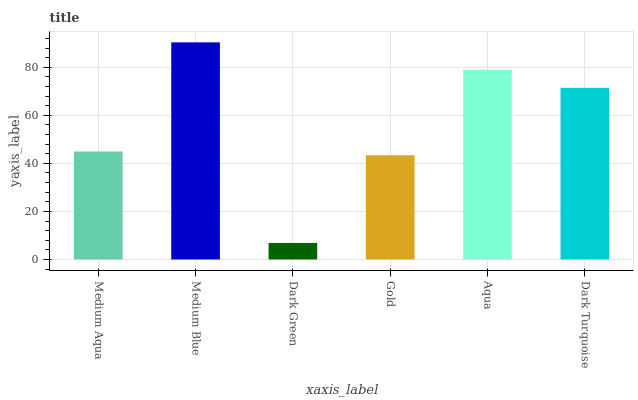Is Dark Green the minimum?
Answer yes or no. Yes. Is Medium Blue the maximum?
Answer yes or no. Yes. Is Medium Blue the minimum?
Answer yes or no. No. Is Dark Green the maximum?
Answer yes or no. No. Is Medium Blue greater than Dark Green?
Answer yes or no. Yes. Is Dark Green less than Medium Blue?
Answer yes or no. Yes. Is Dark Green greater than Medium Blue?
Answer yes or no. No. Is Medium Blue less than Dark Green?
Answer yes or no. No. Is Dark Turquoise the high median?
Answer yes or no. Yes. Is Medium Aqua the low median?
Answer yes or no. Yes. Is Medium Blue the high median?
Answer yes or no. No. Is Dark Green the low median?
Answer yes or no. No. 